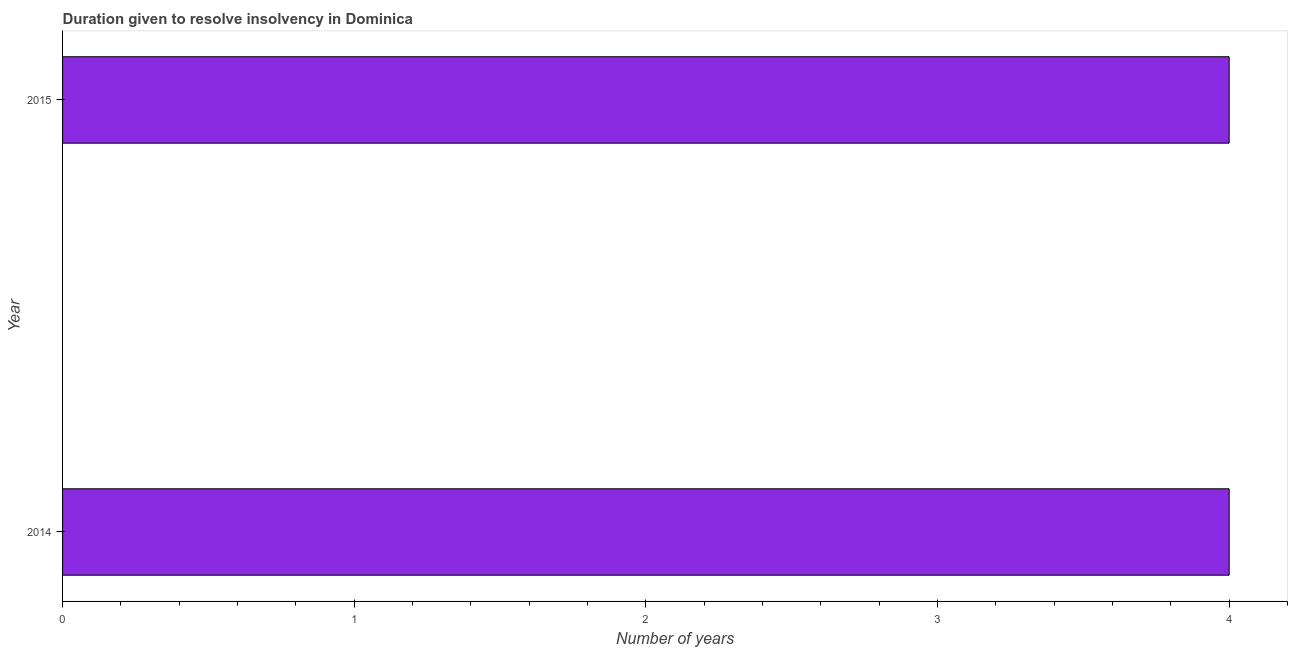Does the graph contain any zero values?
Offer a very short reply. No. What is the title of the graph?
Make the answer very short. Duration given to resolve insolvency in Dominica. What is the label or title of the X-axis?
Give a very brief answer. Number of years. Across all years, what is the maximum number of years to resolve insolvency?
Your answer should be very brief. 4. Across all years, what is the minimum number of years to resolve insolvency?
Your answer should be compact. 4. In which year was the number of years to resolve insolvency maximum?
Offer a terse response. 2014. What is the difference between the number of years to resolve insolvency in 2014 and 2015?
Offer a terse response. 0. What is the average number of years to resolve insolvency per year?
Give a very brief answer. 4. Do a majority of the years between 2015 and 2014 (inclusive) have number of years to resolve insolvency greater than 1.4 ?
Offer a terse response. No. What is the ratio of the number of years to resolve insolvency in 2014 to that in 2015?
Your response must be concise. 1. Is the number of years to resolve insolvency in 2014 less than that in 2015?
Give a very brief answer. No. In how many years, is the number of years to resolve insolvency greater than the average number of years to resolve insolvency taken over all years?
Give a very brief answer. 0. Are all the bars in the graph horizontal?
Your answer should be compact. Yes. How many years are there in the graph?
Keep it short and to the point. 2. Are the values on the major ticks of X-axis written in scientific E-notation?
Your response must be concise. No. What is the Number of years in 2014?
Your answer should be compact. 4. What is the difference between the Number of years in 2014 and 2015?
Offer a very short reply. 0. 